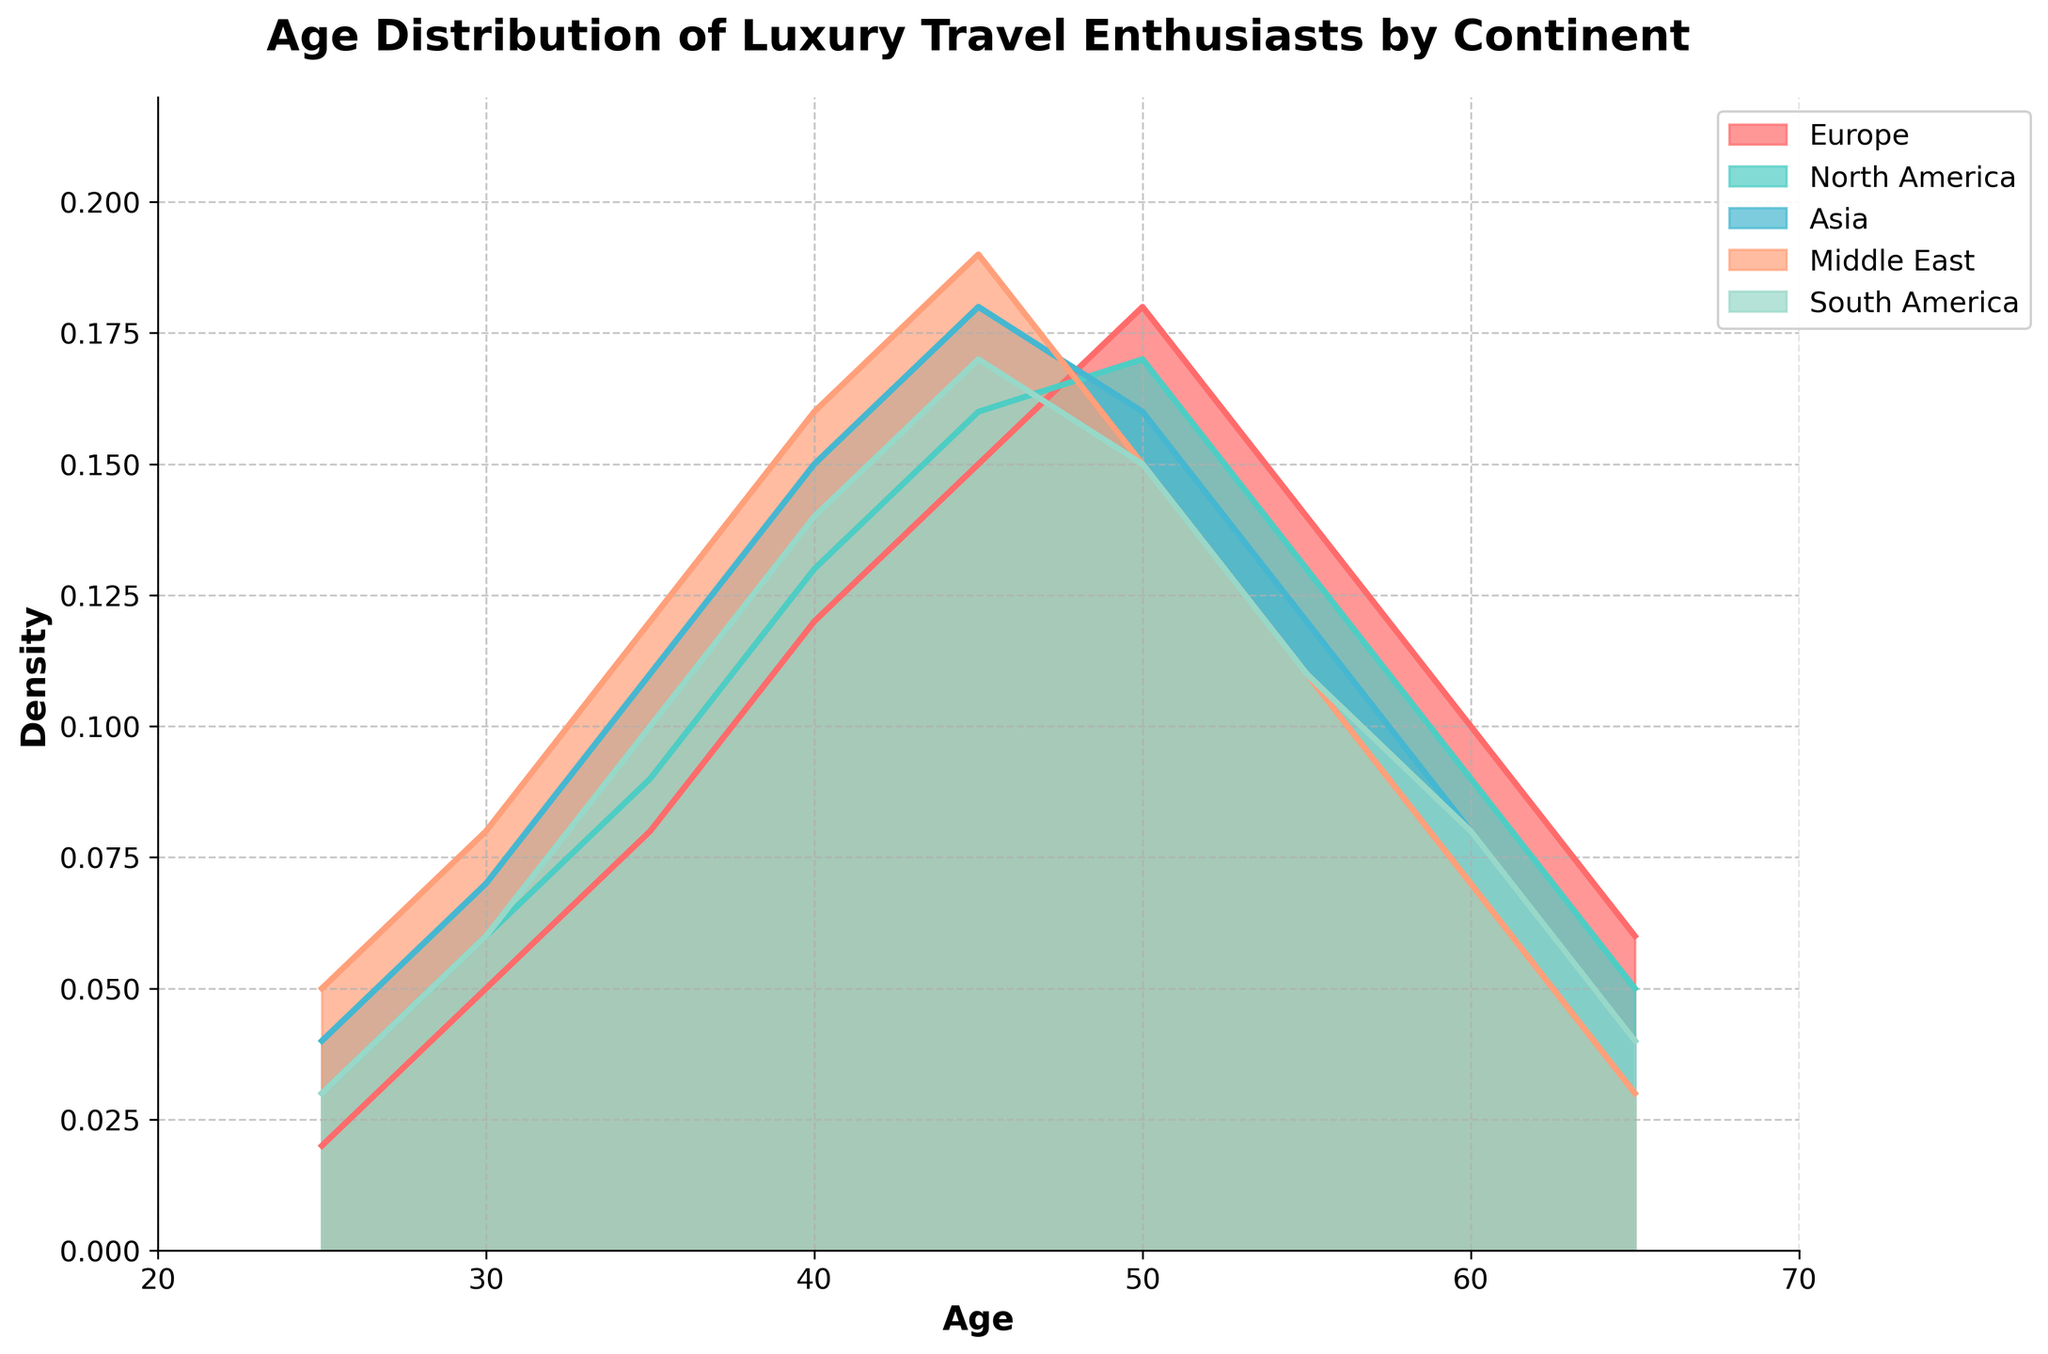What is the age range displayed on the x-axis? The x-axis displays age values starting from 20 up to 70. This is determined by reading the labels on the x-axis from the leftmost to the rightmost point of the plot.
Answer: 20 to 70 Which continent shows the highest density of luxury travel enthusiasts at age 45? To determine this, look for the highest peak on the density plot at age 45 across different colored regions representing continents. The Middle East has the highest peak at this age.
Answer: Middle East How does the density of luxury travel enthusiasts in Europe compare to North America at age 50? Locate age 50 on the x-axis, then compare the respective density values for Europe and North America. Europe's density is slightly lower than North America's at this age.
Answer: North America is higher At what age does Asia's density of luxury travel enthusiasts start to decrease after reaching its peak? Follow the density curve for Asia from its peak and identify the age at which the curve begins to decline. For Asia, the density starts to decrease after age 45.
Answer: 45 Which continent has the broadest range of age distribution with significant density for luxury travel enthusiasts? Observing the spread of the density curves, the continents Europe, North America, and Asia show a broader range but Europe seems to have a prominent gradual spread. Middle East and South America have sharper peaks.
Answer: Europe What is the approximate density of luxury travel enthusiasts in Europe at age 55? Locate age 55 on the x-axis and follow it vertically to intersect with Europe's density curve. The approximate density at this point is 0.14.
Answer: 0.14 Which continent has a higher density of luxury travel enthusiasts at age 30, Asia or South America? Locate age 30 on the x-axis, then compare the density values for Asia and South America. Asia's density is higher at this age.
Answer: Asia At what age does South America reach its peak density of luxury travel enthusiasts? Track the density curve for South America and pinpoint the age at which the peak occurs. South America's peak density occurs at age 45.
Answer: 45 Out of all the continents, which one shows the lowest density at age 65? Identify the density values at age 65 for all continents and compare. The Middle East shows the lowest density at this age.
Answer: Middle East Is the density distribution of luxury travel enthusiasts in the Middle East more skewed towards younger or older ages? Analyze the shape of the density curve for the Middle East and observe which age group (younger or older) has higher densities. The Middle East distribution is skewed towards younger ages.
Answer: Younger ages 